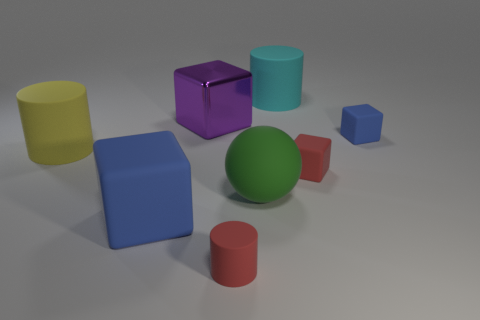Does the large cylinder right of the large blue block have the same material as the yellow object?
Offer a terse response. Yes. What number of cylinders are on the left side of the big green sphere and on the right side of the large yellow thing?
Provide a short and direct response. 1. What is the size of the red rubber thing that is to the right of the red object on the left side of the cyan matte object?
Offer a very short reply. Small. Is there anything else that is made of the same material as the big purple cube?
Make the answer very short. No. Is the number of big metallic cylinders greater than the number of large green objects?
Give a very brief answer. No. Is the color of the matte block that is on the left side of the red cylinder the same as the tiny matte thing that is behind the yellow rubber object?
Offer a terse response. Yes. There is a red matte thing that is on the left side of the cyan matte cylinder; are there any tiny matte cylinders in front of it?
Offer a very short reply. No. Are there fewer large yellow rubber cylinders that are behind the purple thing than rubber cylinders that are in front of the big blue block?
Offer a terse response. Yes. Are the blue block left of the small blue object and the blue thing that is to the right of the big purple shiny thing made of the same material?
Your answer should be compact. Yes. How many small things are red spheres or green spheres?
Offer a terse response. 0. 